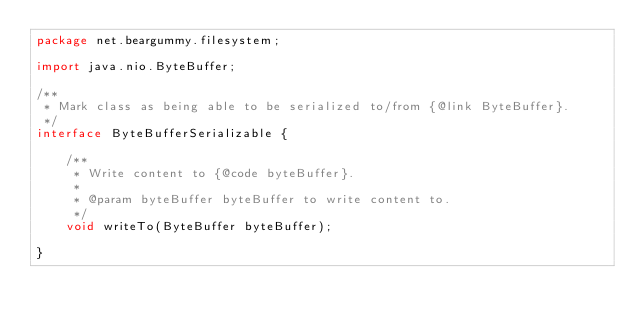<code> <loc_0><loc_0><loc_500><loc_500><_Java_>package net.beargummy.filesystem;

import java.nio.ByteBuffer;

/**
 * Mark class as being able to be serialized to/from {@link ByteBuffer}.
 */
interface ByteBufferSerializable {

    /**
     * Write content to {@code byteBuffer}.
     *
     * @param byteBuffer byteBuffer to write content to.
     */
    void writeTo(ByteBuffer byteBuffer);

}
</code> 